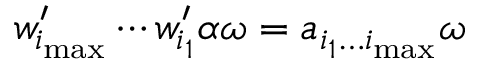<formula> <loc_0><loc_0><loc_500><loc_500>w _ { i _ { \max } } ^ { \prime } \cdots w _ { i _ { 1 } } ^ { \prime } \alpha \omega = a _ { i _ { 1 } \dots i _ { \max } } \omega</formula> 